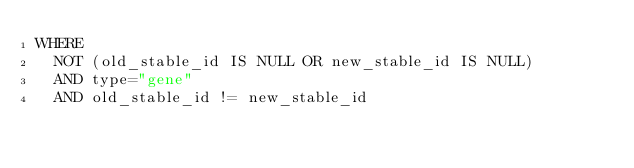<code> <loc_0><loc_0><loc_500><loc_500><_SQL_>WHERE
  NOT (old_stable_id IS NULL OR new_stable_id IS NULL)
  AND type="gene"
  AND old_stable_id != new_stable_id
</code> 